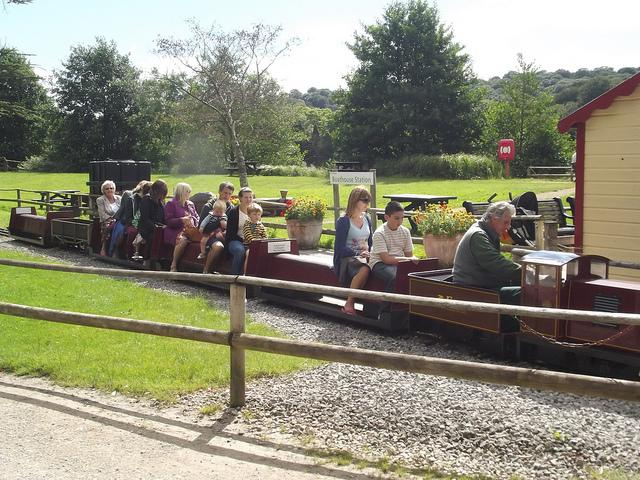What type people ride on this train? Please explain your reasoning. tourists. The train is designed for tourists to sit in and it rides them around on a tour. 